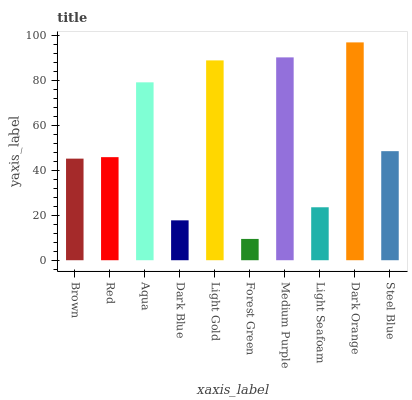Is Forest Green the minimum?
Answer yes or no. Yes. Is Dark Orange the maximum?
Answer yes or no. Yes. Is Red the minimum?
Answer yes or no. No. Is Red the maximum?
Answer yes or no. No. Is Red greater than Brown?
Answer yes or no. Yes. Is Brown less than Red?
Answer yes or no. Yes. Is Brown greater than Red?
Answer yes or no. No. Is Red less than Brown?
Answer yes or no. No. Is Steel Blue the high median?
Answer yes or no. Yes. Is Red the low median?
Answer yes or no. Yes. Is Light Seafoam the high median?
Answer yes or no. No. Is Steel Blue the low median?
Answer yes or no. No. 